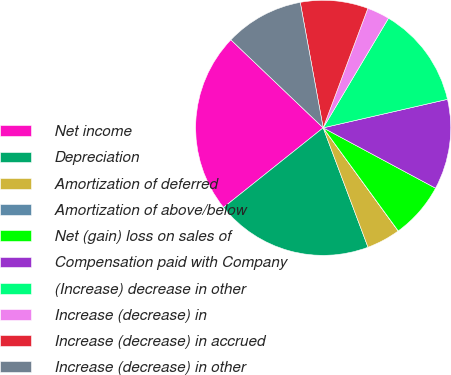Convert chart. <chart><loc_0><loc_0><loc_500><loc_500><pie_chart><fcel>Net income<fcel>Depreciation<fcel>Amortization of deferred<fcel>Amortization of above/below<fcel>Net (gain) loss on sales of<fcel>Compensation paid with Company<fcel>(Increase) decrease in other<fcel>Increase (decrease) in<fcel>Increase (decrease) in accrued<fcel>Increase (decrease) in other<nl><fcel>22.85%<fcel>19.99%<fcel>4.29%<fcel>0.01%<fcel>7.14%<fcel>11.43%<fcel>12.86%<fcel>2.86%<fcel>8.57%<fcel>10.0%<nl></chart> 